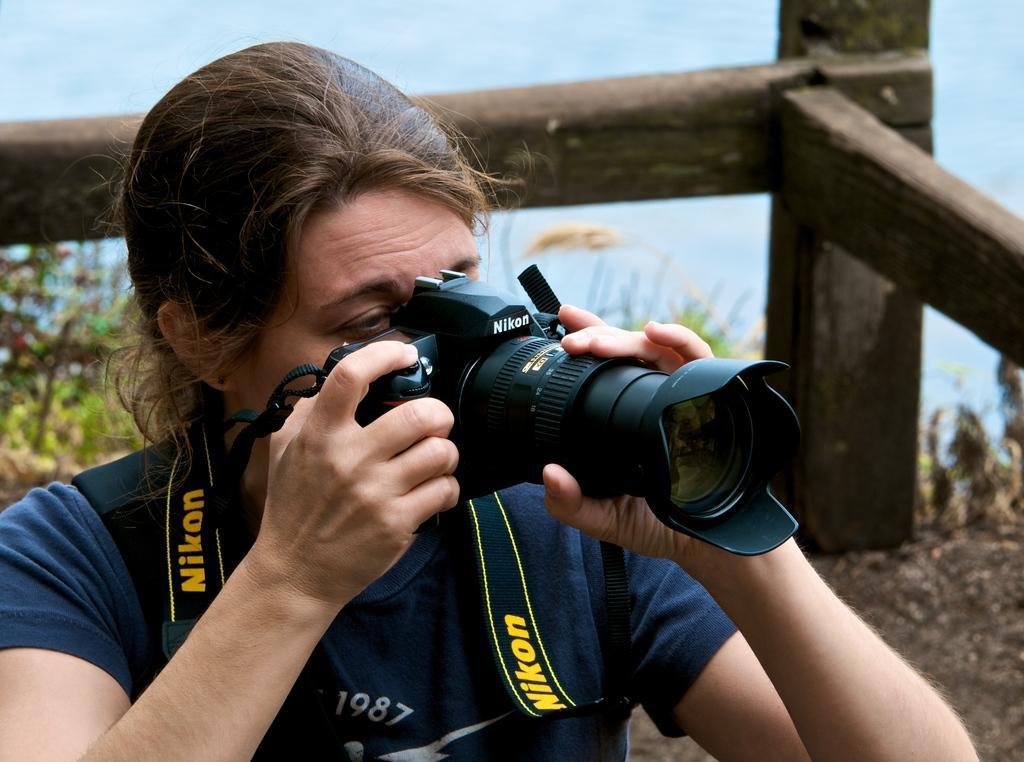How would you summarize this image in a sentence or two? In this image I can see the person is holding the camera. Back I can see the wooden object and small plants. Background is in white and blue color. 